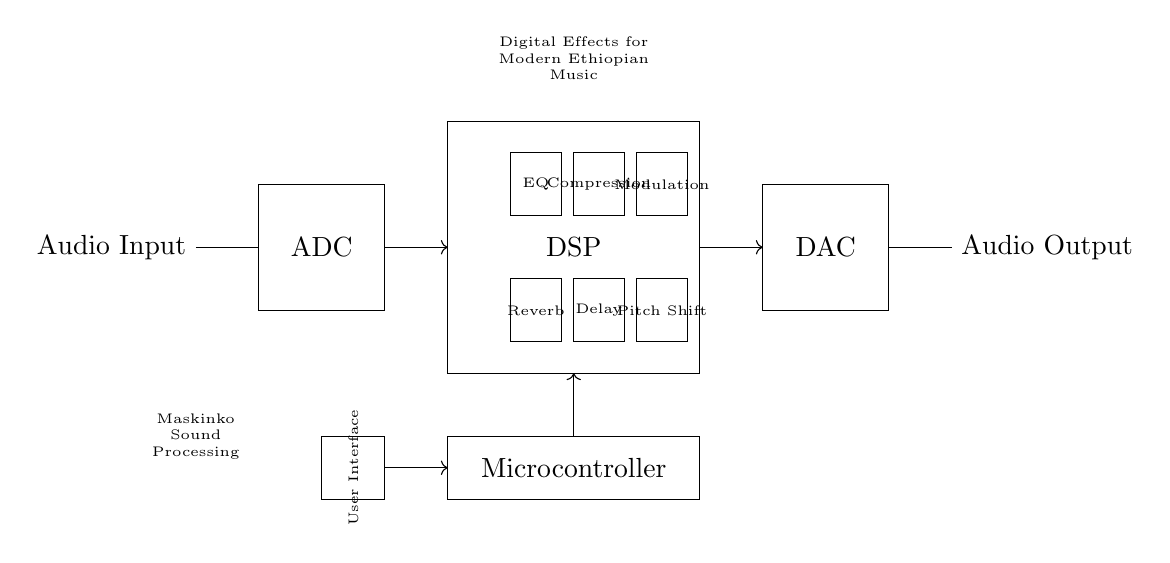What is the main function of the ADC in this circuit? The ADC (Analog-to-Digital Converter) converts the incoming analog audio signal into a digital format for processing. This step is crucial as digital effects can only be applied to digital signals.
Answer: Converts audio What audio effects are included in the DSP section? The DSP (Digital Signal Processor) section contains various effects modules including Reverb, Delay, Pitch Shift, EQ, Compression, and Modulation, which enhance the audio signal in different ways.
Answer: Reverb, Delay, Pitch Shift, EQ, Compression, Modulation What is the role of the Microcontroller in this circuit? The Microcontroller coordinates the entire process by controlling the effects applied in the DSP section and managing the user interface for selecting and adjusting these effects.
Answer: Coordination How are audio signals converted back to analog after processing? After processing, the digital audio signal is converted back to an analog signal through the DAC (Digital-to-Analog Converter) before being outputted, ensuring compatibility with analog audio systems.
Answer: DAC Which component allows user interaction with the digital effects? The User Interface (UI) allows users to interact with the device, adjusting parameters or selecting effects based on their preferences, affecting how the audio is processed.
Answer: User Interface What is the purpose of the effects like Compression in the context of modern Ethiopian music? Compression levels out the dynamics of the audio signal, making quiet sounds louder and loud sounds quieter, which is essential in ensuring the clarity of vocals and instruments characteristic of Ethiopian music.
Answer: Dynamics control 